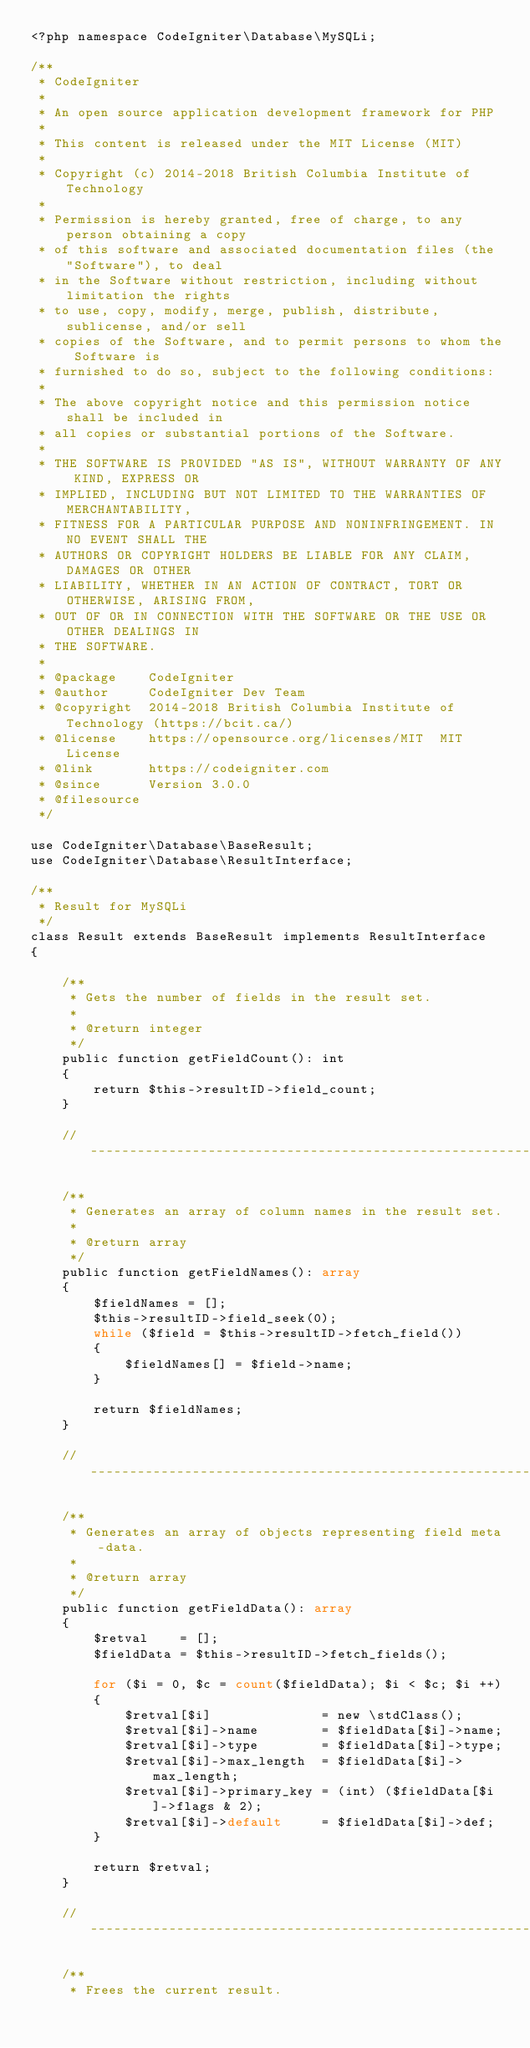<code> <loc_0><loc_0><loc_500><loc_500><_PHP_><?php namespace CodeIgniter\Database\MySQLi;

/**
 * CodeIgniter
 *
 * An open source application development framework for PHP
 *
 * This content is released under the MIT License (MIT)
 *
 * Copyright (c) 2014-2018 British Columbia Institute of Technology
 *
 * Permission is hereby granted, free of charge, to any person obtaining a copy
 * of this software and associated documentation files (the "Software"), to deal
 * in the Software without restriction, including without limitation the rights
 * to use, copy, modify, merge, publish, distribute, sublicense, and/or sell
 * copies of the Software, and to permit persons to whom the Software is
 * furnished to do so, subject to the following conditions:
 *
 * The above copyright notice and this permission notice shall be included in
 * all copies or substantial portions of the Software.
 *
 * THE SOFTWARE IS PROVIDED "AS IS", WITHOUT WARRANTY OF ANY KIND, EXPRESS OR
 * IMPLIED, INCLUDING BUT NOT LIMITED TO THE WARRANTIES OF MERCHANTABILITY,
 * FITNESS FOR A PARTICULAR PURPOSE AND NONINFRINGEMENT. IN NO EVENT SHALL THE
 * AUTHORS OR COPYRIGHT HOLDERS BE LIABLE FOR ANY CLAIM, DAMAGES OR OTHER
 * LIABILITY, WHETHER IN AN ACTION OF CONTRACT, TORT OR OTHERWISE, ARISING FROM,
 * OUT OF OR IN CONNECTION WITH THE SOFTWARE OR THE USE OR OTHER DEALINGS IN
 * THE SOFTWARE.
 *
 * @package    CodeIgniter
 * @author     CodeIgniter Dev Team
 * @copyright  2014-2018 British Columbia Institute of Technology (https://bcit.ca/)
 * @license    https://opensource.org/licenses/MIT	MIT License
 * @link       https://codeigniter.com
 * @since      Version 3.0.0
 * @filesource
 */

use CodeIgniter\Database\BaseResult;
use CodeIgniter\Database\ResultInterface;

/**
 * Result for MySQLi
 */
class Result extends BaseResult implements ResultInterface
{

	/**
	 * Gets the number of fields in the result set.
	 *
	 * @return integer
	 */
	public function getFieldCount(): int
	{
		return $this->resultID->field_count;
	}

	//--------------------------------------------------------------------

	/**
	 * Generates an array of column names in the result set.
	 *
	 * @return array
	 */
	public function getFieldNames(): array
	{
		$fieldNames = [];
		$this->resultID->field_seek(0);
		while ($field = $this->resultID->fetch_field())
		{
			$fieldNames[] = $field->name;
		}

		return $fieldNames;
	}

	//--------------------------------------------------------------------

	/**
	 * Generates an array of objects representing field meta-data.
	 *
	 * @return array
	 */
	public function getFieldData(): array
	{
		$retval    = [];
		$fieldData = $this->resultID->fetch_fields();

		for ($i = 0, $c = count($fieldData); $i < $c; $i ++)
		{
			$retval[$i]              = new \stdClass();
			$retval[$i]->name        = $fieldData[$i]->name;
			$retval[$i]->type        = $fieldData[$i]->type;
			$retval[$i]->max_length  = $fieldData[$i]->max_length;
			$retval[$i]->primary_key = (int) ($fieldData[$i]->flags & 2);
			$retval[$i]->default     = $fieldData[$i]->def;
		}

		return $retval;
	}

	//--------------------------------------------------------------------

	/**
	 * Frees the current result.</code> 